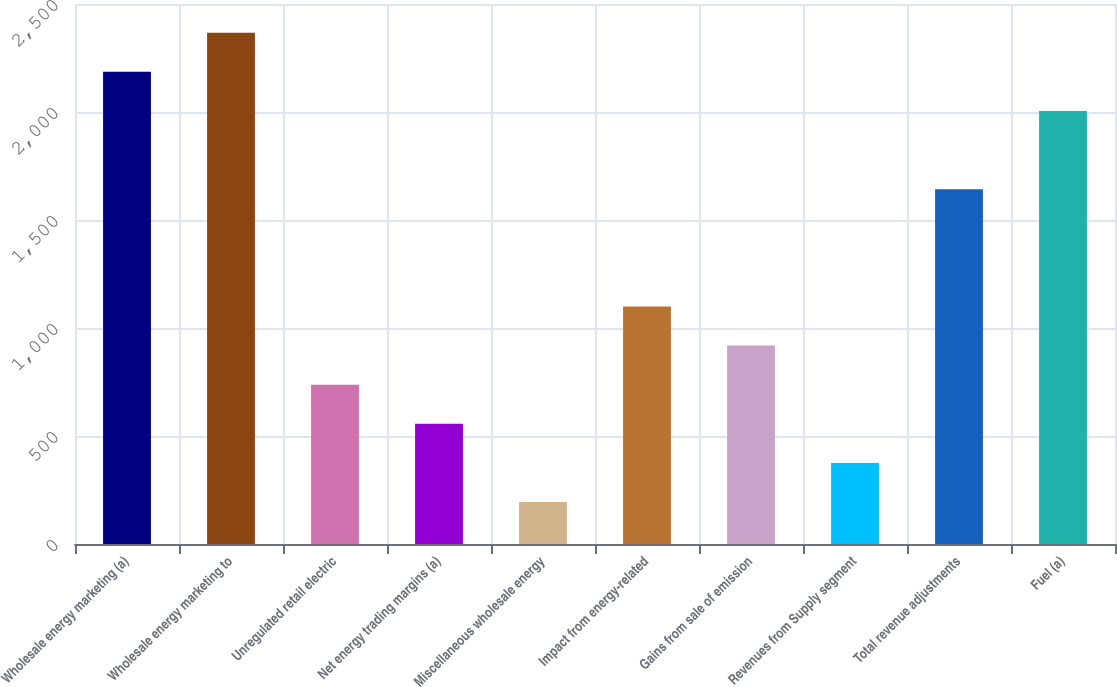<chart> <loc_0><loc_0><loc_500><loc_500><bar_chart><fcel>Wholesale energy marketing (a)<fcel>Wholesale energy marketing to<fcel>Unregulated retail electric<fcel>Net energy trading margins (a)<fcel>Miscellaneous wholesale energy<fcel>Impact from energy-related<fcel>Gains from sale of emission<fcel>Revenues from Supply segment<fcel>Total revenue adjustments<fcel>Fuel (a)<nl><fcel>2186.2<fcel>2367.3<fcel>737.4<fcel>556.3<fcel>194.1<fcel>1099.6<fcel>918.5<fcel>375.2<fcel>1642.9<fcel>2005.1<nl></chart> 